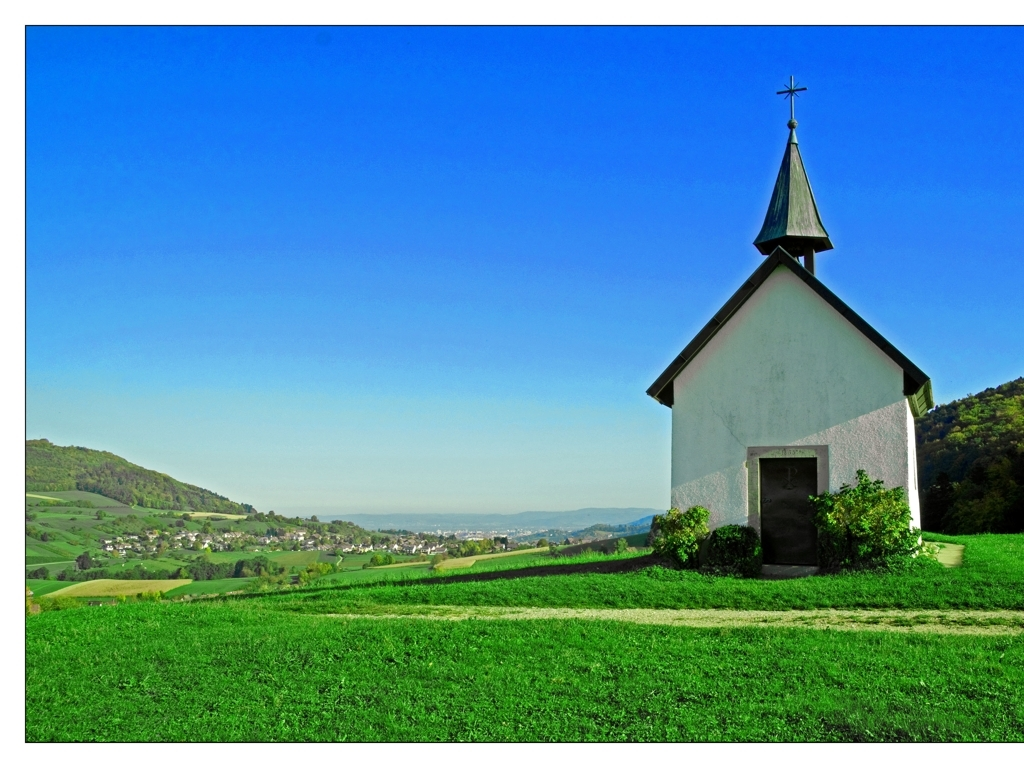What can this image tell us about the local climate? The image conveys a temperate climate, probably springtime or summer, based on the lush green fields and the vibrant, leafy trees visible in the background. The sky is clear without any signs of recent precipitation, which suggests fair weather conditions prevalent in the region. 